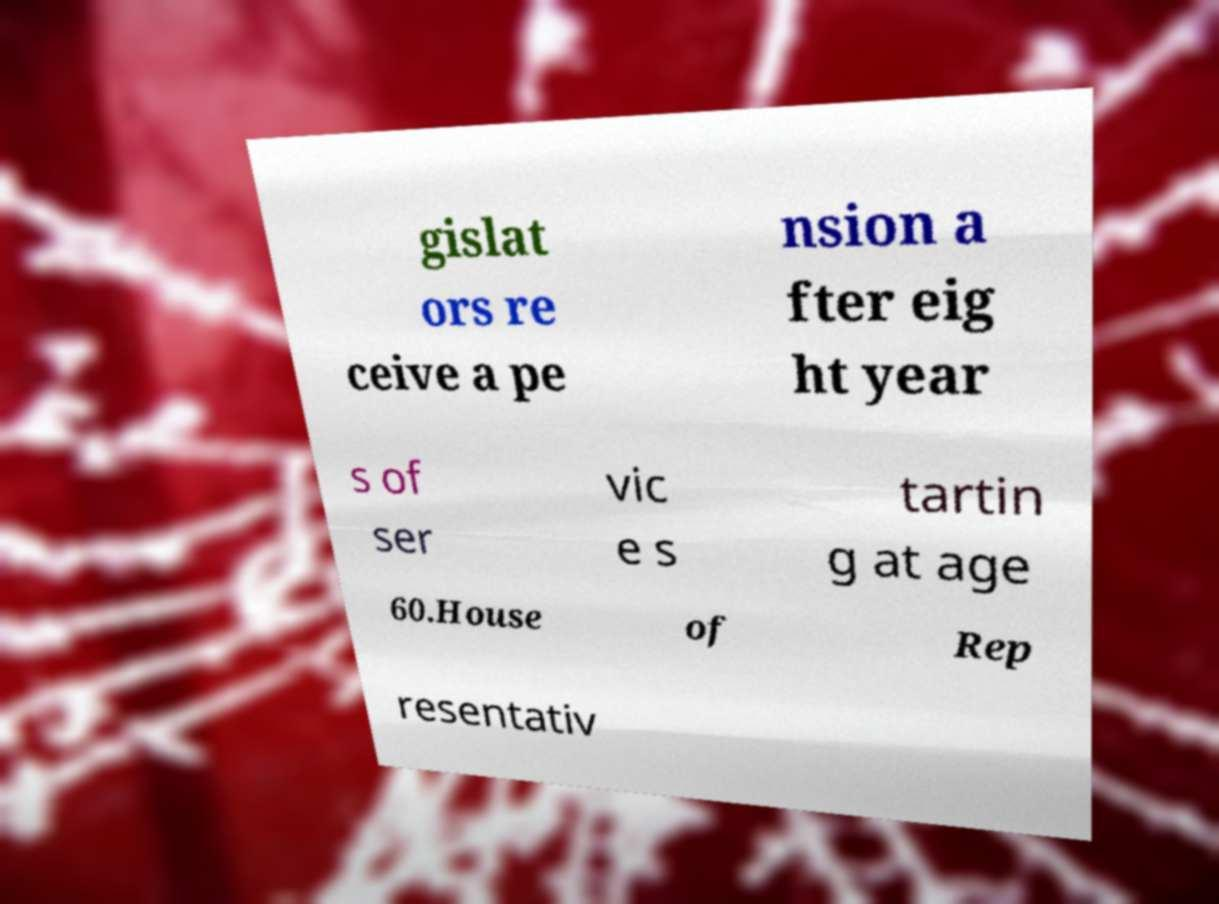Please identify and transcribe the text found in this image. gislat ors re ceive a pe nsion a fter eig ht year s of ser vic e s tartin g at age 60.House of Rep resentativ 